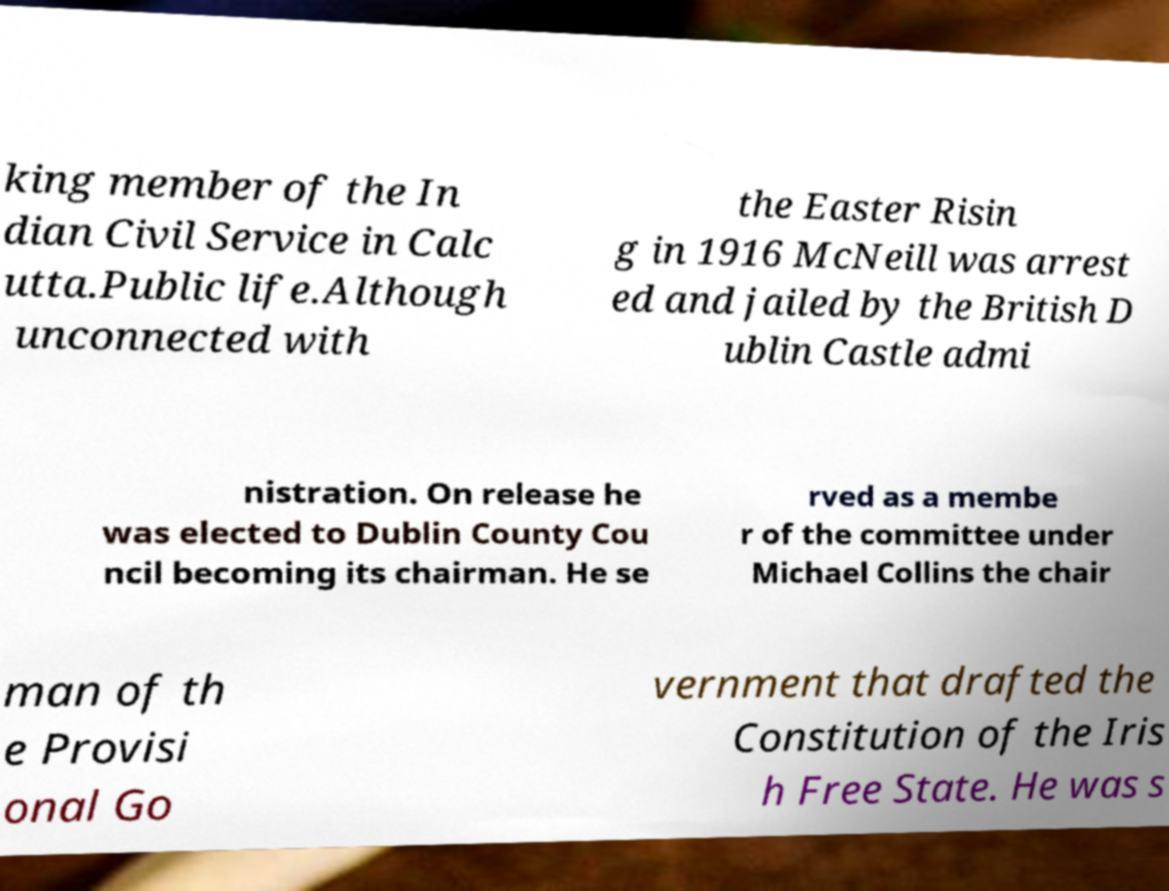For documentation purposes, I need the text within this image transcribed. Could you provide that? king member of the In dian Civil Service in Calc utta.Public life.Although unconnected with the Easter Risin g in 1916 McNeill was arrest ed and jailed by the British D ublin Castle admi nistration. On release he was elected to Dublin County Cou ncil becoming its chairman. He se rved as a membe r of the committee under Michael Collins the chair man of th e Provisi onal Go vernment that drafted the Constitution of the Iris h Free State. He was s 